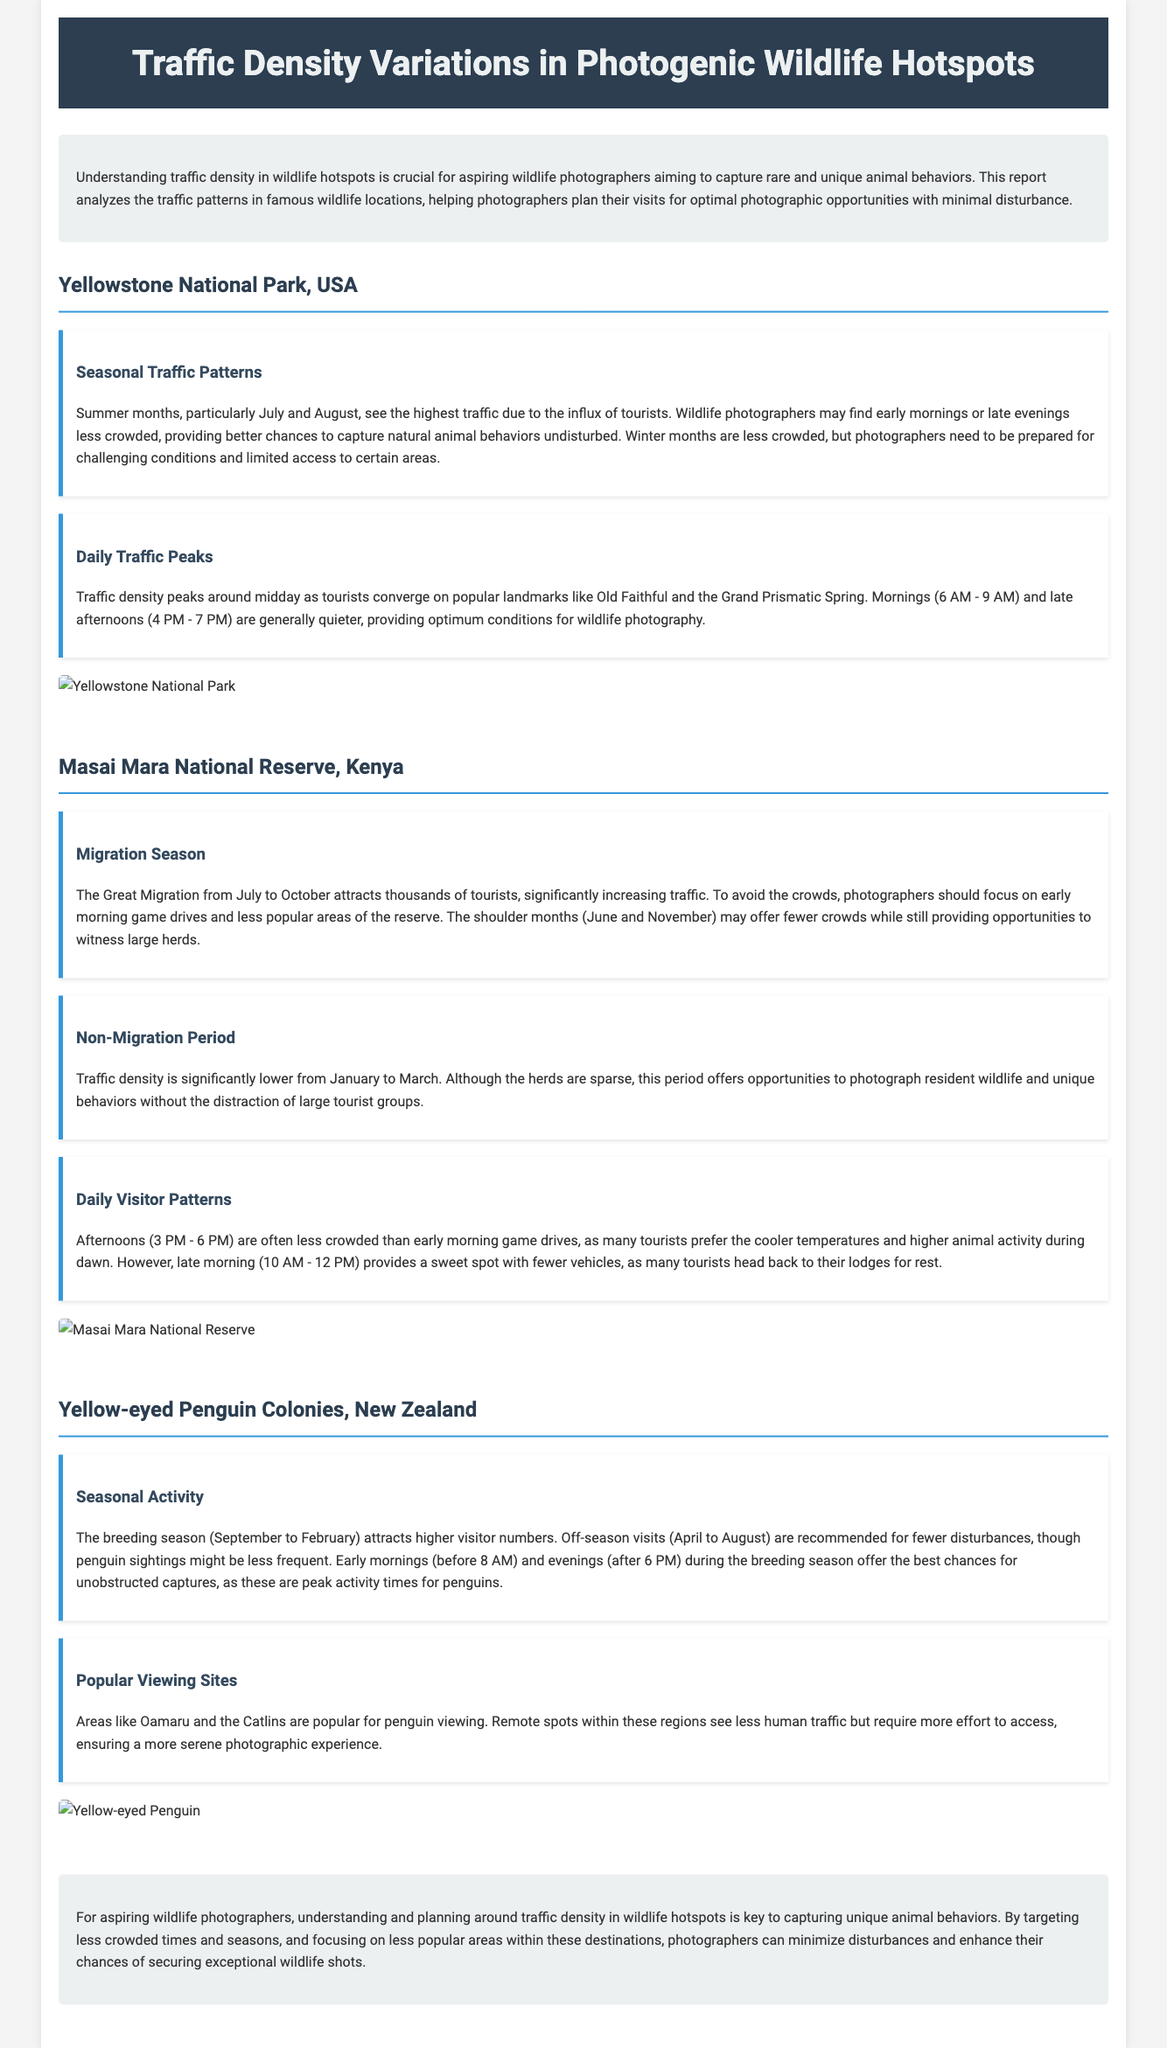what is the highest traffic season in Yellowstone National Park? The highest traffic season in Yellowstone National Park is the summer months, particularly July and August.
Answer: summer months when do traffic peaks occur in Yellowstone? Traffic peaks occur around midday as tourists converge on popular landmarks.
Answer: midday what months see the Great Migration in Masai Mara National Reserve? The Great Migration occurs from July to October.
Answer: July to October when is traffic density significantly lower in Masai Mara? Traffic density is significantly lower from January to March.
Answer: January to March what time is best for unobstructed captures of yellow-eyed penguins? Early mornings (before 8 AM) and evenings (after 6 PM) offer the best chances for unobstructed captures.
Answer: early mornings and evenings how can photographers avoid crowds in the Masai Mara? Photographers should focus on early morning game drives and less popular areas.
Answer: early morning game drives which locations are recommended for penguin viewing? Popular viewing sites include Oamaru and the Catlins.
Answer: Oamaru and the Catlins what is the effect of traffic on wildlife photography? Understanding traffic density helps to capture unique animal behaviors with minimal disturbance.
Answer: minimal disturbance what time is generally quieter for wildlife photography in Yellowstone? Mornings (6 AM - 9 AM) and late afternoons (4 PM - 7 PM) are generally quieter.
Answer: mornings and late afternoons 